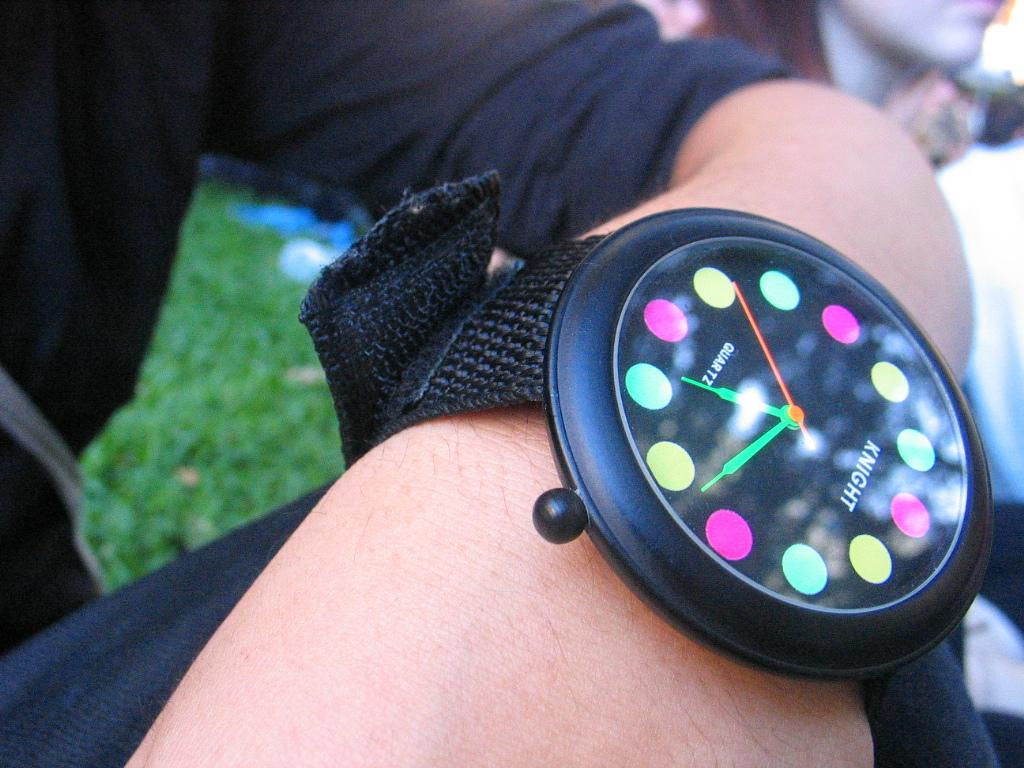Provide a one-sentence caption for the provided image. A colorful watch says Knight on the face. 